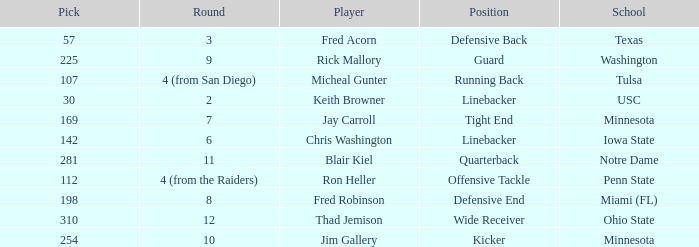Which Round is pick 112 in? 4 (from the Raiders). 